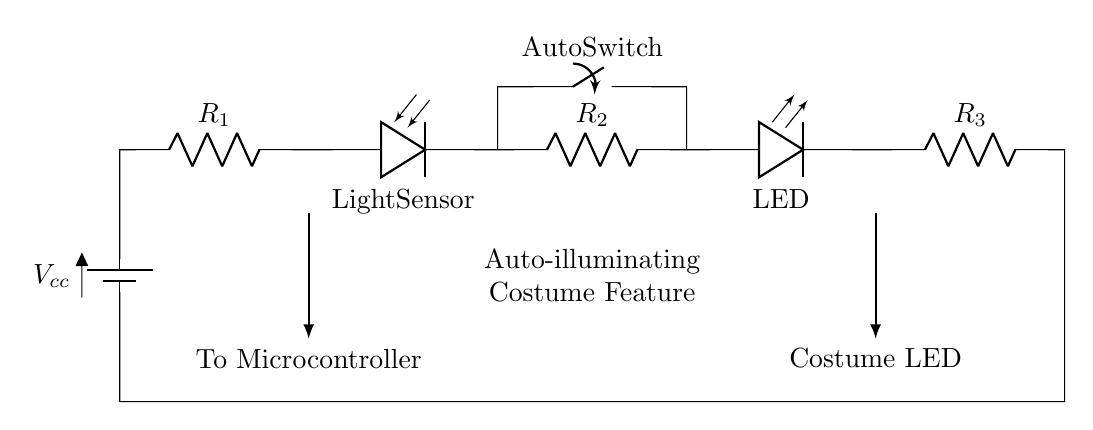What type of circuit is this? This is a series circuit, indicated by the layout where components are connected one after another. In a series circuit, the current flows through each component sequentially, without branching.
Answer: Series circuit What is the role of the light sensor? The light sensor detects light intensity and allows current to flow when a certain light level is met. It is placed in series, meaning its operation affects the entire circuit's function and illumination activation.
Answer: Detects light How many resistors are present in the circuit? There are three resistors (R1, R2, and R3) visible in the circuit diagram. They are placed in series, which affects the overall resistance and current flow in the circuit.
Answer: Three Which component indicates the presence of light in this circuit? The light sensor is the component that indicates the presence of light by controlling the current based on light intensity. When the light is sufficient, it allows the LEDs to illuminate.
Answer: Light sensor What happens when the auto switch is closed? Closing the auto switch creates a complete circuit for the current to flow through, allowing the LED to light up, assuming the light sensor detects adequate light. This indicates activation of the auto-illuminating feature.
Answer: LED lights up What is the purpose of the auto switch? The auto switch serves to manually override or enable the circuit, allowing control over the illumination feature regardless of the light sensor's state. It ensures flexibility in the costume's lighting management.
Answer: Manual control 